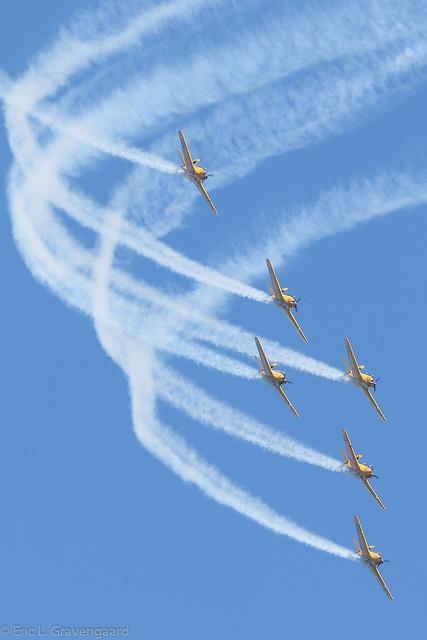Is the sky blue with white jet trails?
Short answer required. Yes. How many planes are there?
Give a very brief answer. 6. What is happening in this photo?
Short answer required. Flight show. 